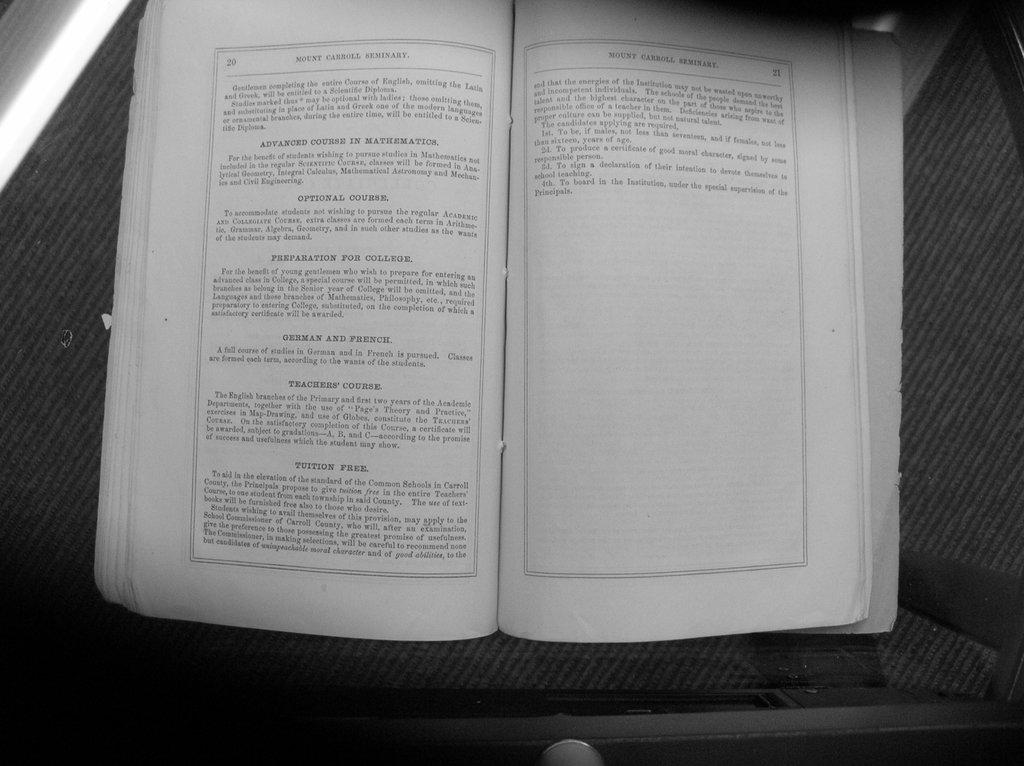What page is this book on?
Offer a very short reply. Unanswerable. What is the name of this book?
Give a very brief answer. Mount carroll seminary. 